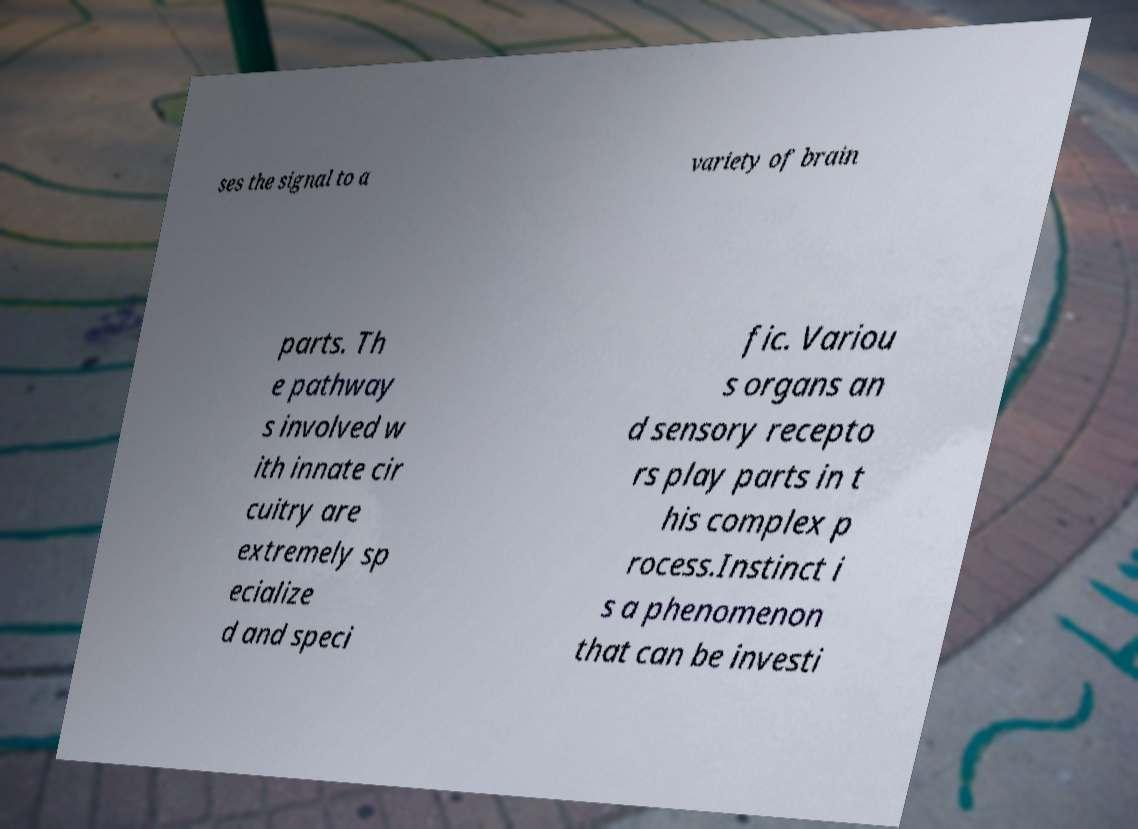Can you read and provide the text displayed in the image?This photo seems to have some interesting text. Can you extract and type it out for me? ses the signal to a variety of brain parts. Th e pathway s involved w ith innate cir cuitry are extremely sp ecialize d and speci fic. Variou s organs an d sensory recepto rs play parts in t his complex p rocess.Instinct i s a phenomenon that can be investi 